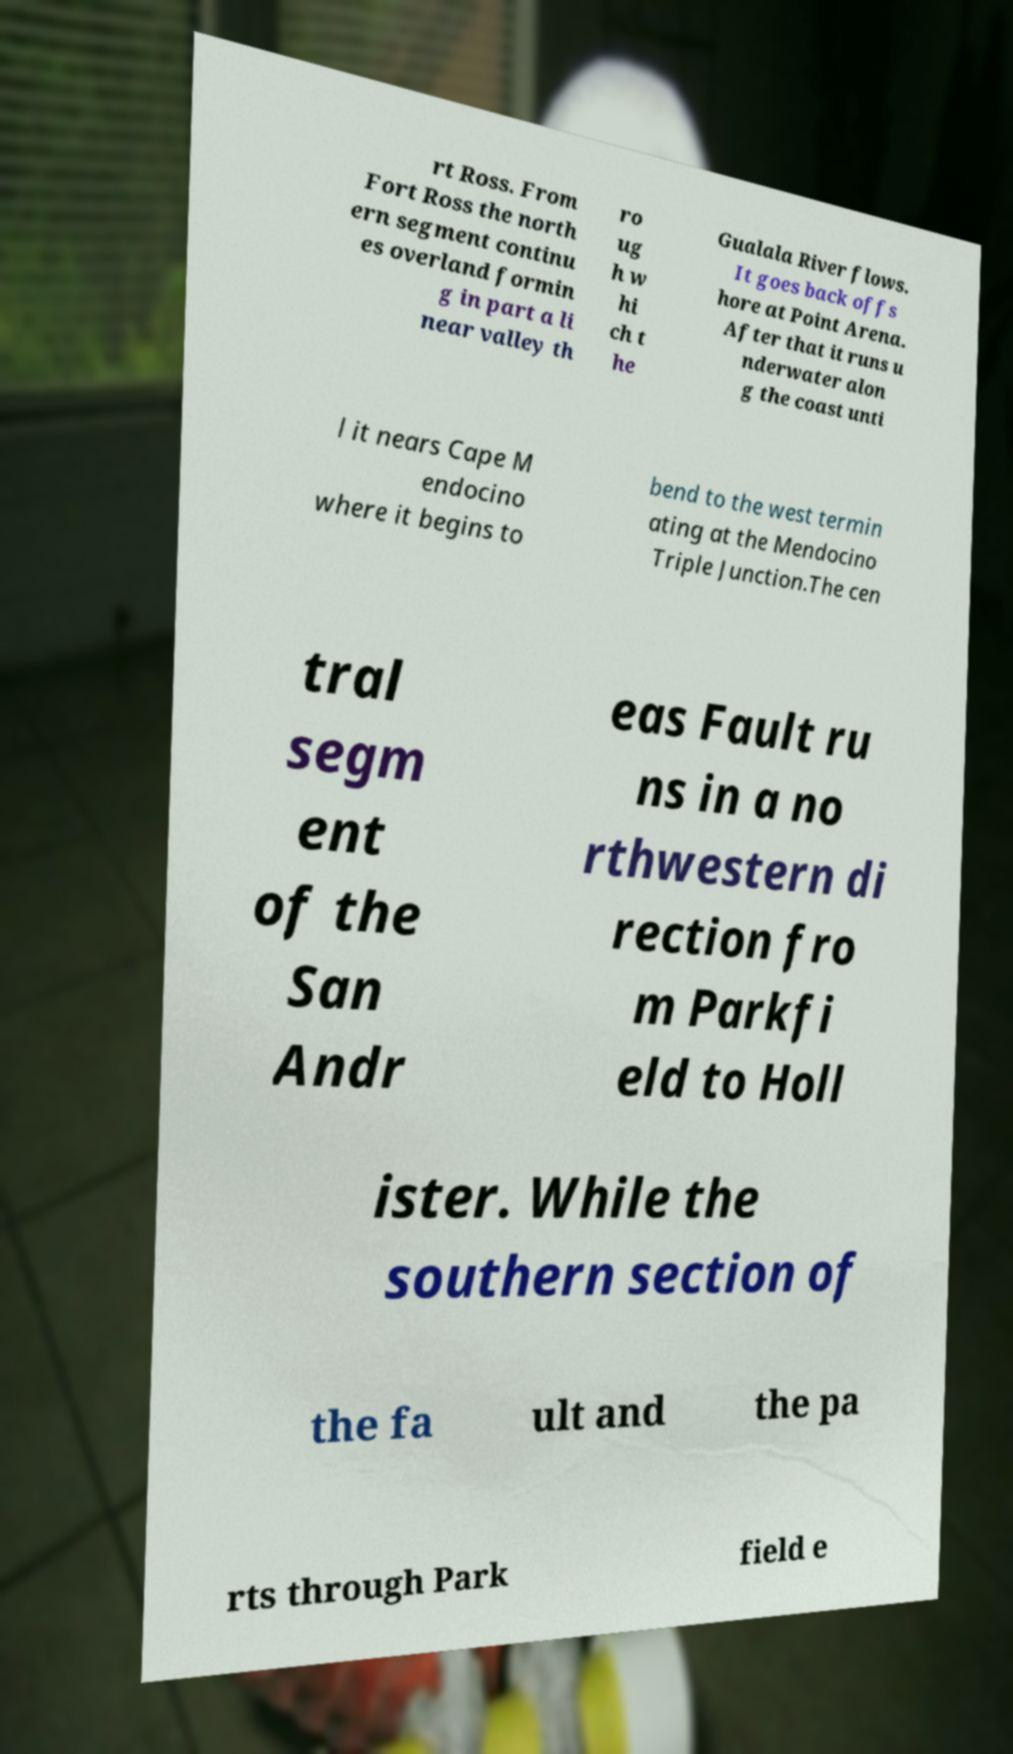Please identify and transcribe the text found in this image. rt Ross. From Fort Ross the north ern segment continu es overland formin g in part a li near valley th ro ug h w hi ch t he Gualala River flows. It goes back offs hore at Point Arena. After that it runs u nderwater alon g the coast unti l it nears Cape M endocino where it begins to bend to the west termin ating at the Mendocino Triple Junction.The cen tral segm ent of the San Andr eas Fault ru ns in a no rthwestern di rection fro m Parkfi eld to Holl ister. While the southern section of the fa ult and the pa rts through Park field e 